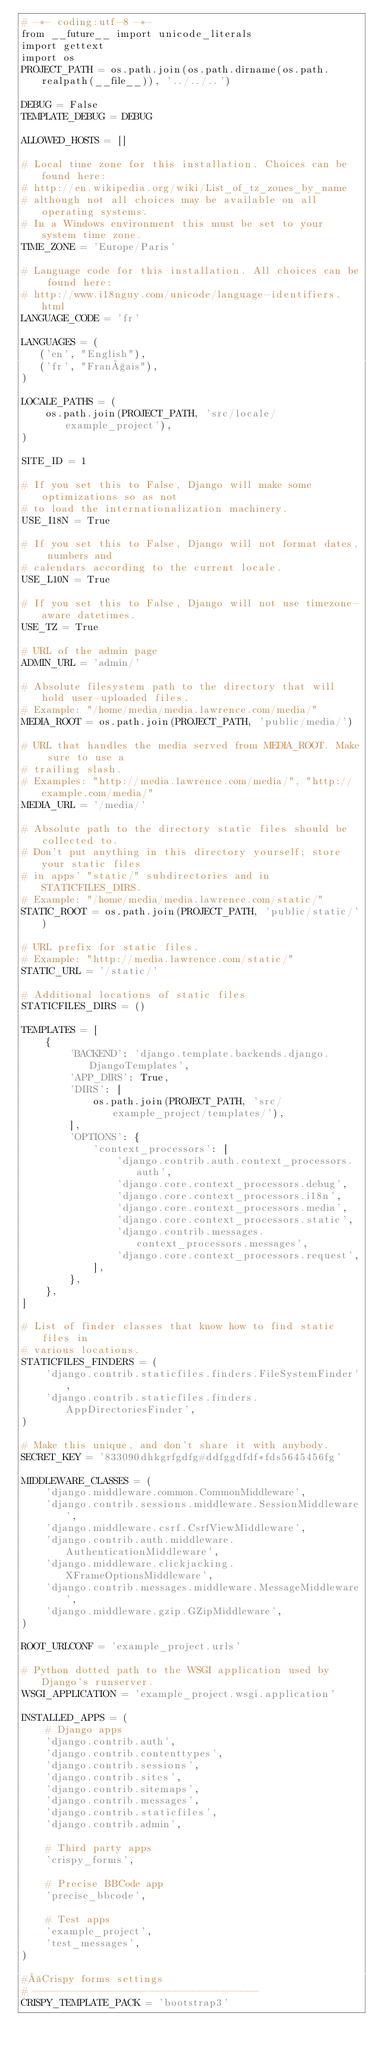<code> <loc_0><loc_0><loc_500><loc_500><_Python_># -*- coding:utf-8 -*-
from __future__ import unicode_literals
import gettext
import os
PROJECT_PATH = os.path.join(os.path.dirname(os.path.realpath(__file__)), '../../..')

DEBUG = False
TEMPLATE_DEBUG = DEBUG

ALLOWED_HOSTS = []

# Local time zone for this installation. Choices can be found here:
# http://en.wikipedia.org/wiki/List_of_tz_zones_by_name
# although not all choices may be available on all operating systems.
# In a Windows environment this must be set to your system time zone.
TIME_ZONE = 'Europe/Paris'

# Language code for this installation. All choices can be found here:
# http://www.i18nguy.com/unicode/language-identifiers.html
LANGUAGE_CODE = 'fr'

LANGUAGES = (
   ('en', "English"),
   ('fr', "Français"),
)

LOCALE_PATHS = (
    os.path.join(PROJECT_PATH, 'src/locale/example_project'),
)

SITE_ID = 1

# If you set this to False, Django will make some optimizations so as not
# to load the internationalization machinery.
USE_I18N = True

# If you set this to False, Django will not format dates, numbers and
# calendars according to the current locale.
USE_L10N = True

# If you set this to False, Django will not use timezone-aware datetimes.
USE_TZ = True

# URL of the admin page
ADMIN_URL = 'admin/'

# Absolute filesystem path to the directory that will hold user-uploaded files.
# Example: "/home/media/media.lawrence.com/media/"
MEDIA_ROOT = os.path.join(PROJECT_PATH, 'public/media/')

# URL that handles the media served from MEDIA_ROOT. Make sure to use a
# trailing slash.
# Examples: "http://media.lawrence.com/media/", "http://example.com/media/"
MEDIA_URL = '/media/'

# Absolute path to the directory static files should be collected to.
# Don't put anything in this directory yourself; store your static files
# in apps' "static/" subdirectories and in STATICFILES_DIRS.
# Example: "/home/media/media.lawrence.com/static/"
STATIC_ROOT = os.path.join(PROJECT_PATH, 'public/static/')

# URL prefix for static files.
# Example: "http://media.lawrence.com/static/"
STATIC_URL = '/static/'

# Additional locations of static files
STATICFILES_DIRS = ()

TEMPLATES = [
    {
        'BACKEND': 'django.template.backends.django.DjangoTemplates',
        'APP_DIRS': True,
        'DIRS': [
            os.path.join(PROJECT_PATH, 'src/example_project/templates/'),
        ],
        'OPTIONS': {
            'context_processors': [
                'django.contrib.auth.context_processors.auth',
                'django.core.context_processors.debug',
                'django.core.context_processors.i18n',
                'django.core.context_processors.media',
                'django.core.context_processors.static',
                'django.contrib.messages.context_processors.messages',
                'django.core.context_processors.request',
            ],
        },
    },
]

# List of finder classes that know how to find static files in
# various locations.
STATICFILES_FINDERS = (
    'django.contrib.staticfiles.finders.FileSystemFinder',
    'django.contrib.staticfiles.finders.AppDirectoriesFinder',
)

# Make this unique, and don't share it with anybody.
SECRET_KEY = '833090dhkgrfgdfg#ddfggdfdf*fds5645456fg'

MIDDLEWARE_CLASSES = (
    'django.middleware.common.CommonMiddleware',
    'django.contrib.sessions.middleware.SessionMiddleware',
    'django.middleware.csrf.CsrfViewMiddleware',
    'django.contrib.auth.middleware.AuthenticationMiddleware',
    'django.middleware.clickjacking.XFrameOptionsMiddleware',
    'django.contrib.messages.middleware.MessageMiddleware',
    'django.middleware.gzip.GZipMiddleware',
)

ROOT_URLCONF = 'example_project.urls'

# Python dotted path to the WSGI application used by Django's runserver.
WSGI_APPLICATION = 'example_project.wsgi.application'

INSTALLED_APPS = (
    # Django apps
    'django.contrib.auth',
    'django.contrib.contenttypes',
    'django.contrib.sessions',
    'django.contrib.sites',
    'django.contrib.sitemaps',
    'django.contrib.messages',
    'django.contrib.staticfiles',
    'django.contrib.admin',

    # Third party apps
    'crispy_forms',

    # Precise BBCode app
    'precise_bbcode',

    # Test apps
    'example_project',
    'test_messages',
)

# Crispy forms settings
# --------------------------------------
CRISPY_TEMPLATE_PACK = 'bootstrap3'
</code> 